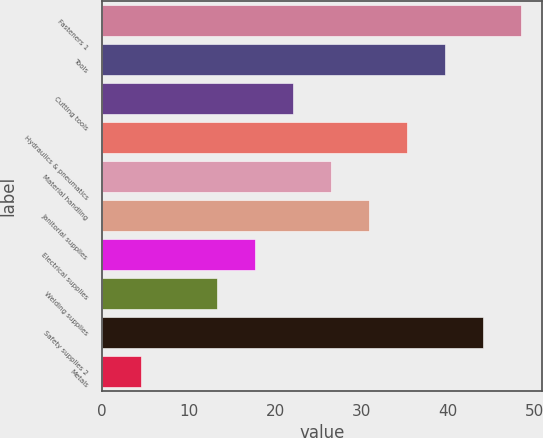Convert chart to OTSL. <chart><loc_0><loc_0><loc_500><loc_500><bar_chart><fcel>Fasteners 1<fcel>Tools<fcel>Cutting tools<fcel>Hydraulics & pneumatics<fcel>Material handling<fcel>Janitorial supplies<fcel>Electrical supplies<fcel>Welding supplies<fcel>Safety supplies 2<fcel>Metals<nl><fcel>48.39<fcel>39.61<fcel>22.05<fcel>35.22<fcel>26.44<fcel>30.83<fcel>17.66<fcel>13.27<fcel>44<fcel>4.49<nl></chart> 